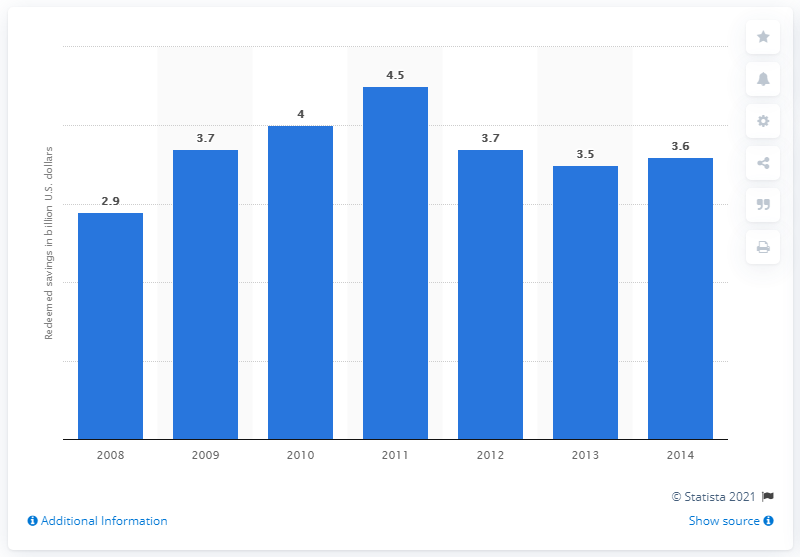Point out several critical features in this image. The total savings from redeemed CPG coupons in 2011 was 4.5... 